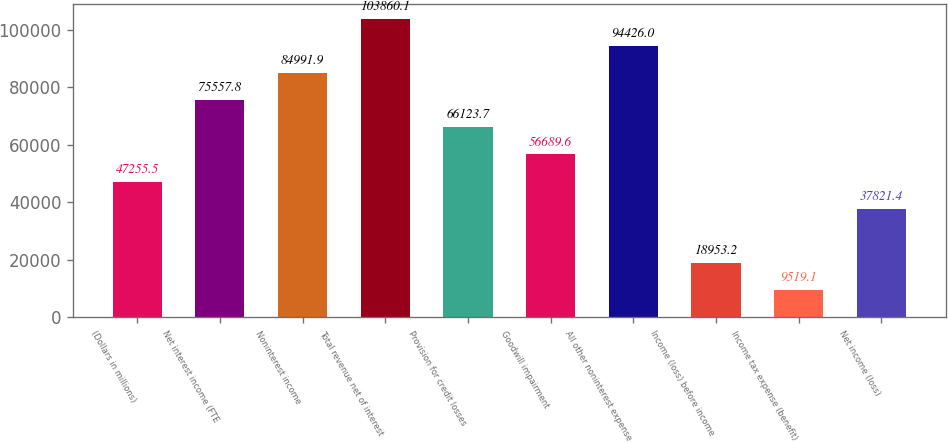Convert chart. <chart><loc_0><loc_0><loc_500><loc_500><bar_chart><fcel>(Dollars in millions)<fcel>Net interest income (FTE<fcel>Noninterest income<fcel>Total revenue net of interest<fcel>Provision for credit losses<fcel>Goodwill impairment<fcel>All other noninterest expense<fcel>Income (loss) before income<fcel>Income tax expense (benefit)<fcel>Net income (loss)<nl><fcel>47255.5<fcel>75557.8<fcel>84991.9<fcel>103860<fcel>66123.7<fcel>56689.6<fcel>94426<fcel>18953.2<fcel>9519.1<fcel>37821.4<nl></chart> 